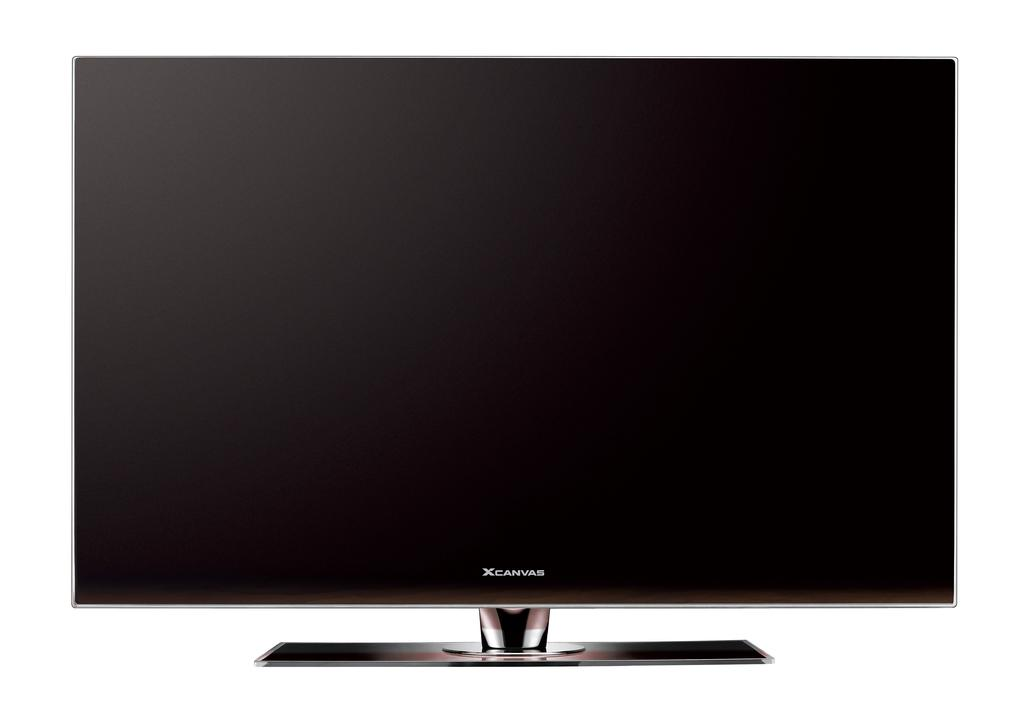<image>
Create a compact narrative representing the image presented. a television that has xcanvas written on it 